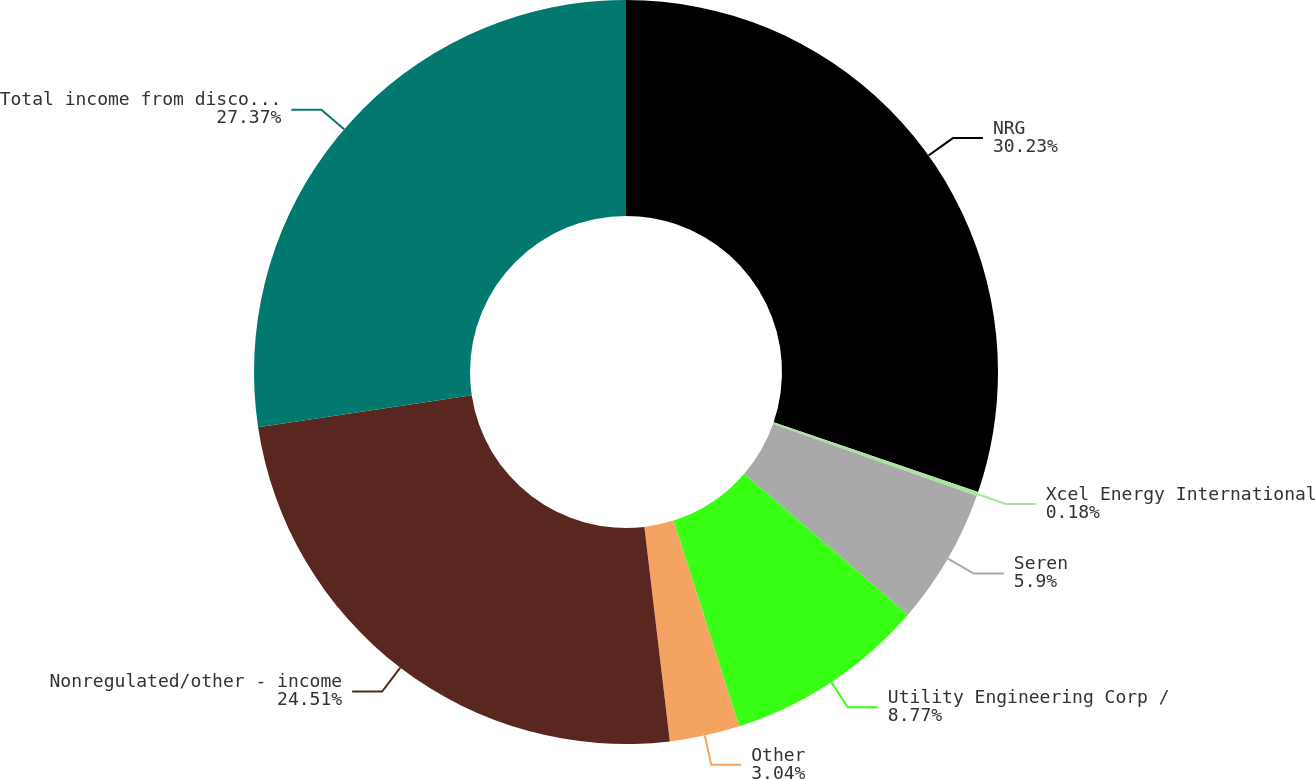<chart> <loc_0><loc_0><loc_500><loc_500><pie_chart><fcel>NRG<fcel>Xcel Energy International<fcel>Seren<fcel>Utility Engineering Corp /<fcel>Other<fcel>Nonregulated/other - income<fcel>Total income from discontinued<nl><fcel>30.23%<fcel>0.18%<fcel>5.9%<fcel>8.77%<fcel>3.04%<fcel>24.51%<fcel>27.37%<nl></chart> 